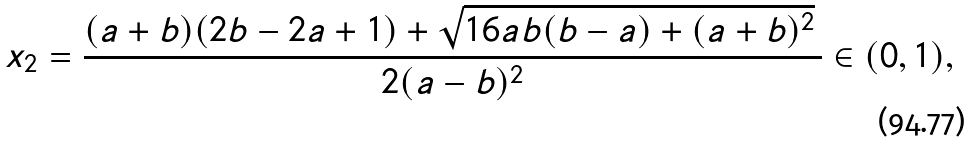<formula> <loc_0><loc_0><loc_500><loc_500>x _ { 2 } = \frac { ( a + b ) ( 2 b - 2 a + 1 ) + \sqrt { 1 6 a b ( b - a ) + ( a + b ) ^ { 2 } } \, } { 2 ( a - b ) ^ { 2 } } \in ( 0 , 1 ) ,</formula> 